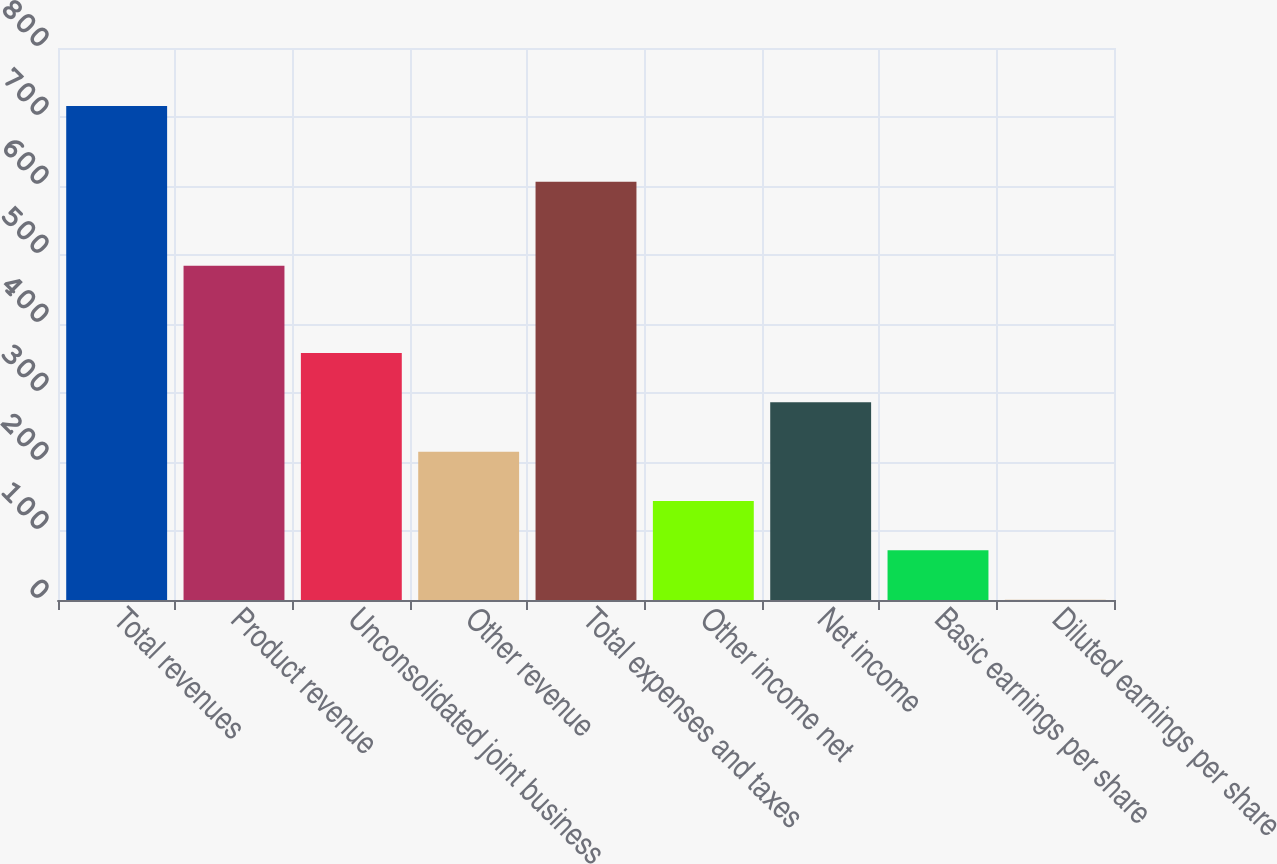Convert chart. <chart><loc_0><loc_0><loc_500><loc_500><bar_chart><fcel>Total revenues<fcel>Product revenue<fcel>Unconsolidated joint business<fcel>Other revenue<fcel>Total expenses and taxes<fcel>Other income net<fcel>Net income<fcel>Basic earnings per share<fcel>Diluted earnings per share<nl><fcel>715.9<fcel>484.4<fcel>358.13<fcel>215.03<fcel>606.1<fcel>143.48<fcel>286.58<fcel>71.93<fcel>0.38<nl></chart> 